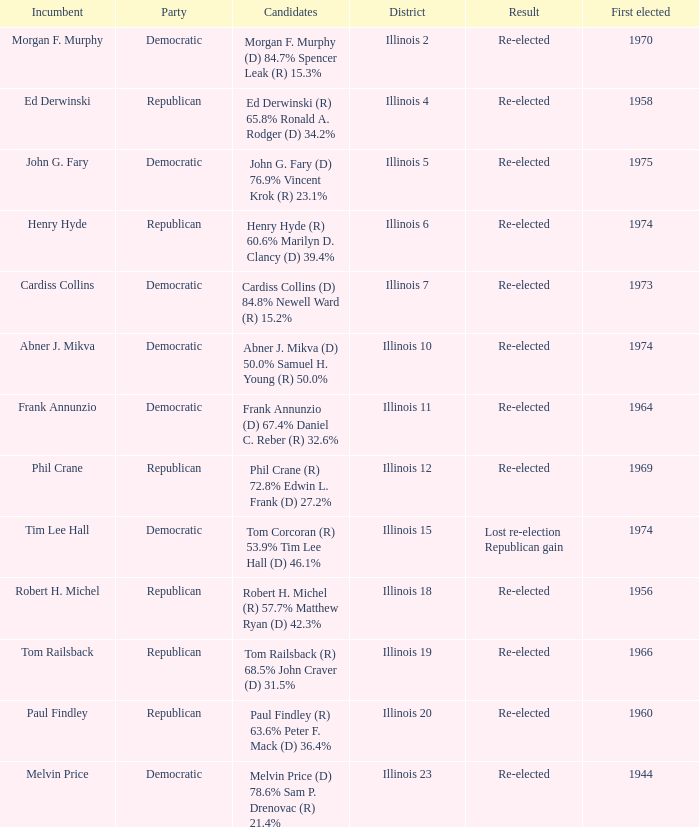Name the candidates for illinois 15 Tom Corcoran (R) 53.9% Tim Lee Hall (D) 46.1%. 